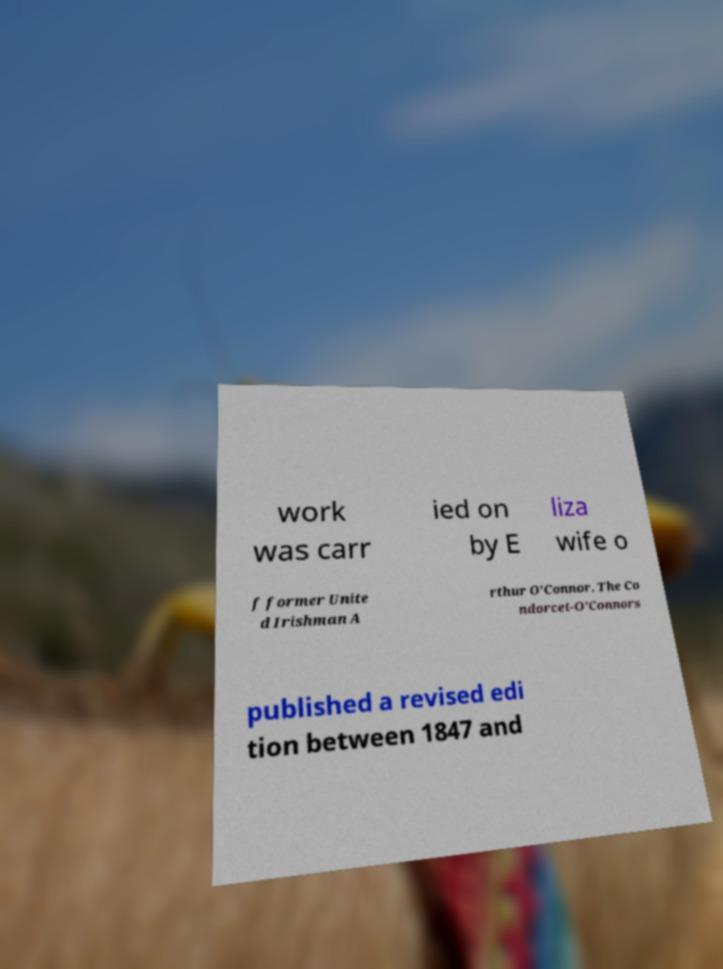Can you read and provide the text displayed in the image?This photo seems to have some interesting text. Can you extract and type it out for me? work was carr ied on by E liza wife o f former Unite d Irishman A rthur O'Connor. The Co ndorcet-O'Connors published a revised edi tion between 1847 and 